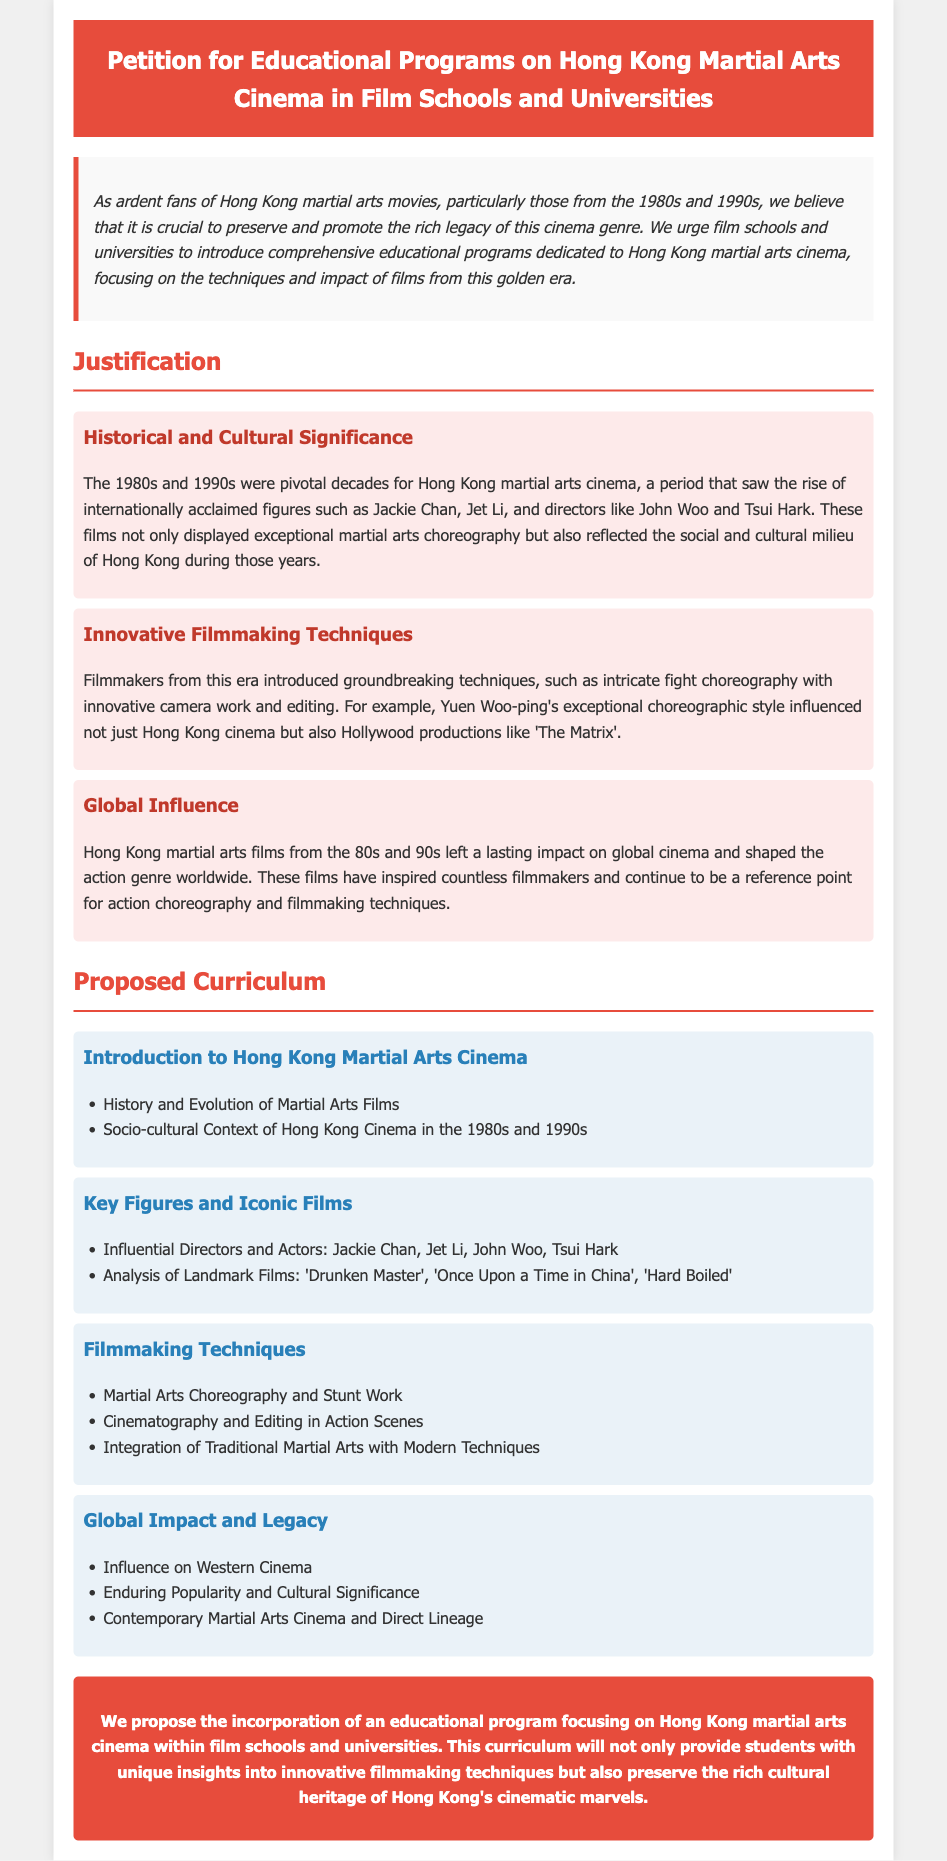What are the pivotal decades for Hong Kong martial arts cinema? The document states that the 1980s and 1990s were pivotal decades for Hong Kong martial arts cinema.
Answer: 1980s and 1990s Who are some internationally acclaimed figures mentioned? The document mentions Jackie Chan and Jet Li as internationally acclaimed figures from that era.
Answer: Jackie Chan, Jet Li What filmmaking technique is highlighted in the document? The document highlights groundbreaking techniques such as intricate fight choreography and innovative camera work.
Answer: Intricate fight choreography, innovative camera work Which film is analyzed under the "Key Figures and Iconic Films" module? The document lists "Drunken Master" as a landmark film analyzed under the Key Figures and Iconic Films module.
Answer: Drunken Master What is proposed for film schools and universities? The document proposes the incorporation of an educational program focused on Hong Kong martial arts cinema in film schools and universities.
Answer: Educational program focused on Hong Kong martial arts cinema What genre of cinema do the educational programs aim to preserve? The educational programs aim to preserve the heritage of Hong Kong's cinematic marvels, particularly the martial arts genre.
Answer: Martial arts genre What aspect of cultural significance is mentioned in the justification? The justification includes the enduring popularity and cultural significance of martial arts films.
Answer: Enduring popularity and cultural significance Who is one of the influential directors named in the document? The document names John Woo as one of the influential directors in Hong Kong martial arts cinema.
Answer: John Woo 